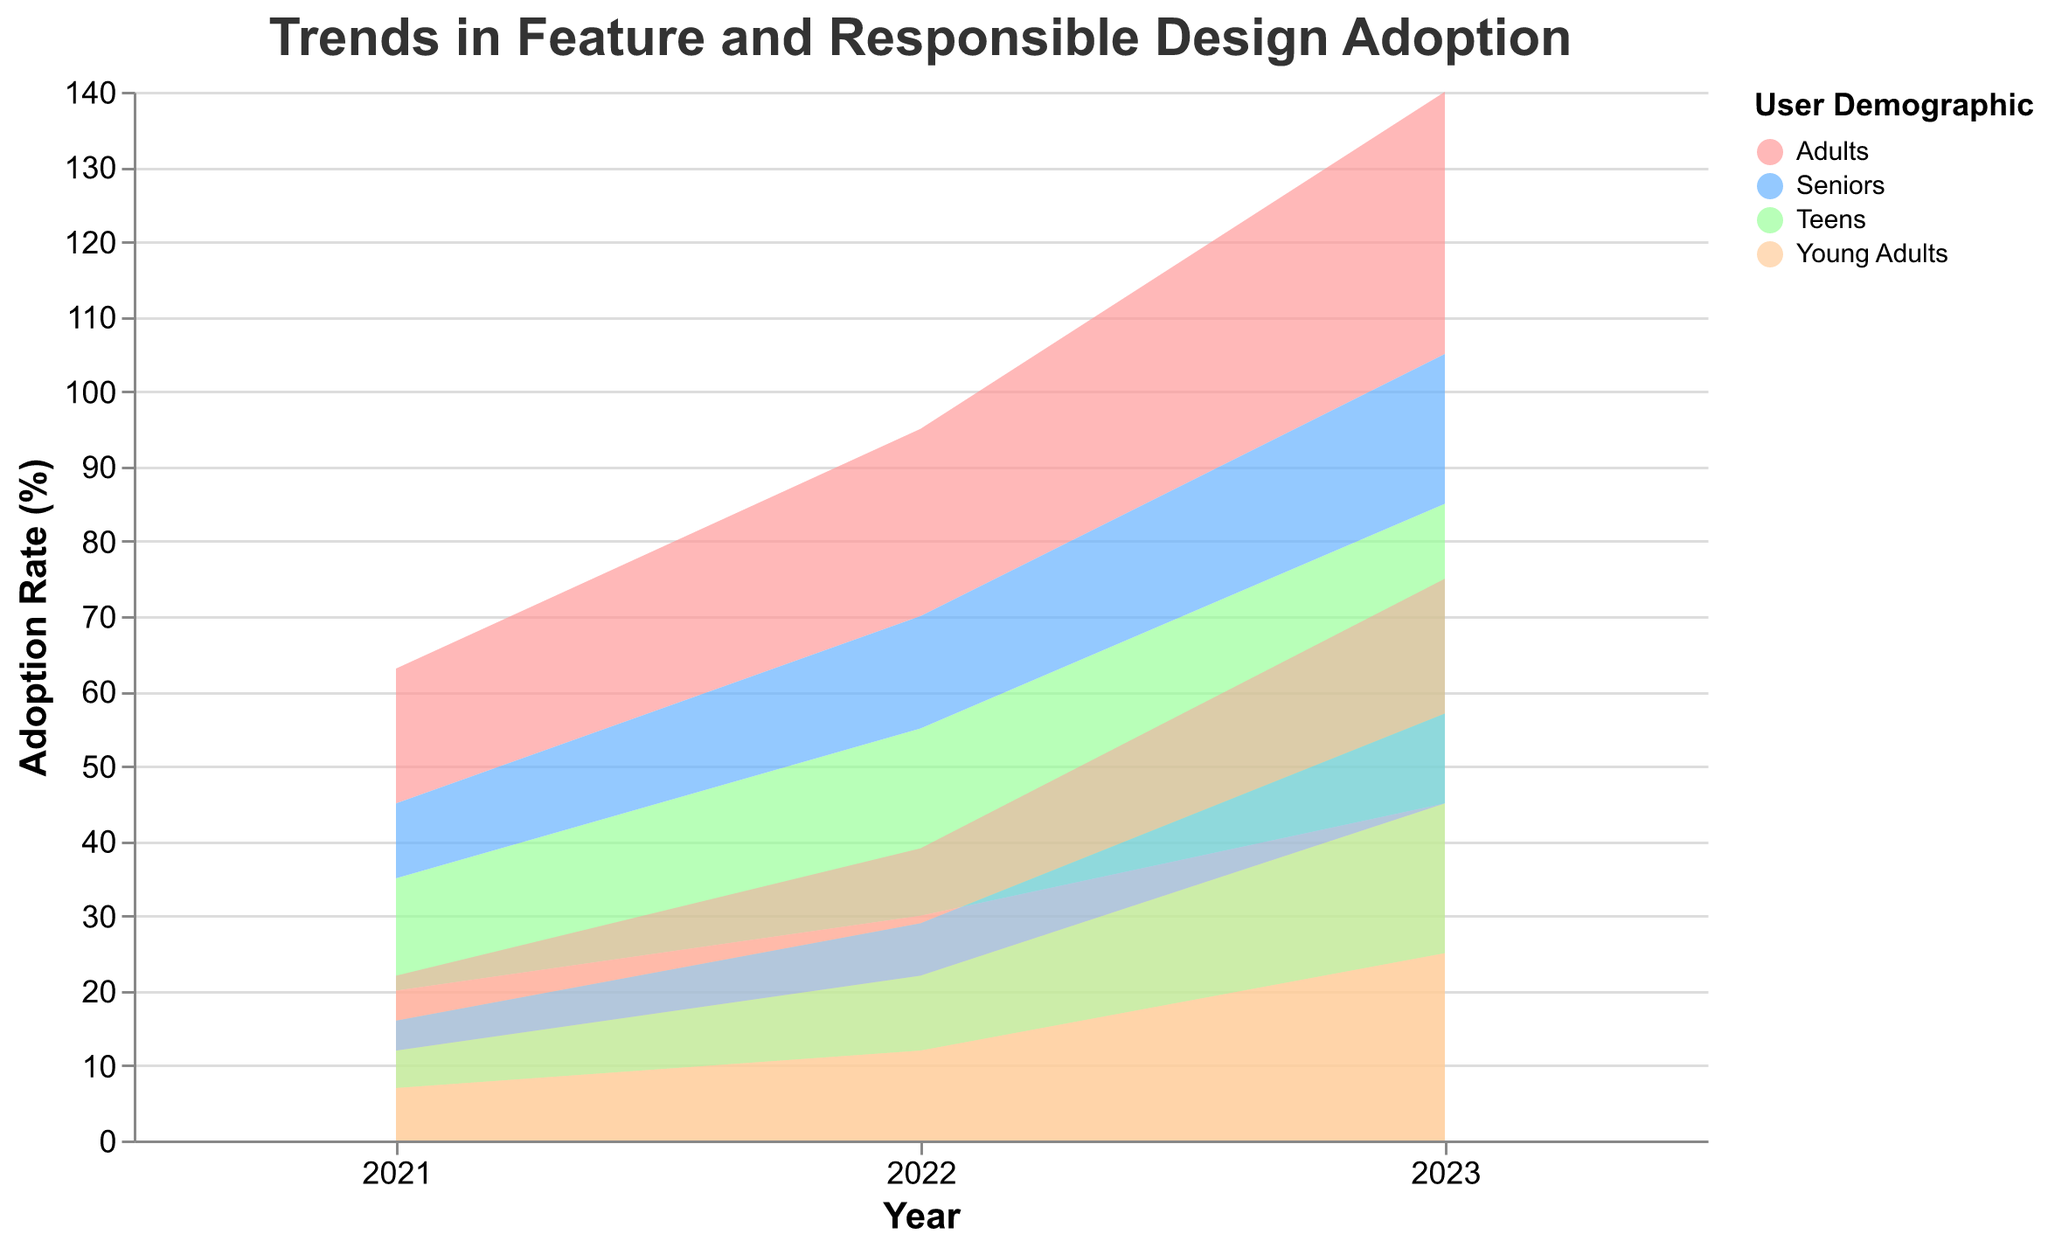What is the title of the figure? The title of a figure is typically displayed at the top. Here, it reads "Trends in Feature and Responsible Design Adoption".
Answer: Trends in Feature and Responsible Design Adoption How many user demographics are displayed in the figure? The legend of the figure shows the different user demographics. There are four listed: Teens, Young Adults, Adults, and Seniors.
Answer: 4 Which user demographic had the highest rate of feature adoption in 2023? Checking the color-coded areas for 2023, the "Young Adults" category shows the highest level of feature adoption.
Answer: Young Adults Which year had the biggest increase in responsible design adoption for Teens? Comparing the values specifically for "Teens" over the years, in 2021 it was 5%, in 2022 it became 10%, and in 2023 it reached 20%. The biggest increase happened from 2022 to 2023.
Answer: 2023 What is the feature adoption rate for "Seniors" in 2022? Looking at the point on the chart where "Seniors" and 2022 intersect, the feature adoption rate is shown to be 15%.
Answer: 15% Did Adults have a higher or lower responsible design adoption rate than Teens in 2021? For 2021, looking at the values, Adults had a rate of 6%, while Teens had a rate of 5%. Therefore, Adults had a higher rate.
Answer: Higher Compare the feature adoption rate of "Young Adults" and "Seniors" in 2023. The figure shows that in 2023, Young Adults had a feature adoption rate of 45%, whereas Seniors had 20%. Young Adults had a much higher rate.
Answer: Young Adults had a higher rate What is the total adoption rate (feature and responsible design) for Adults in 2023? Adding the feature adoption rate (35%) to the responsible design adoption rate (18%) for Adults in 2023 gives a total of 53%.
Answer: 53% Which user demographic showed the least change in responsible design adoption from 2021 to 2023? Calculating the changes for each demographic: Teens (5% to 20%), Young Adults (7% to 25%), Adults (6% to 18%), and Seniors (4% to 12%). Seniors had the least change, with an increase of only 8%.
Answer: Seniors What’s the difference between the feature adoption rates of Teens and Adults in 2022? Subtracting the feature adoption rate for Adults (25%) from that of Teens (25%) in 2022 results in a difference of 0%.
Answer: 0% 